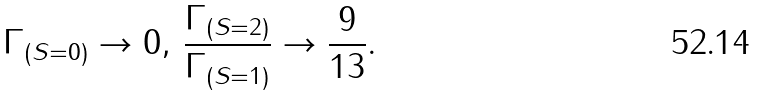<formula> <loc_0><loc_0><loc_500><loc_500>\Gamma _ { ( S = 0 ) } \rightarrow 0 , \, \frac { \Gamma _ { ( S = 2 ) } } { \Gamma _ { ( S = 1 ) } } \rightarrow \frac { 9 } { 1 3 } .</formula> 